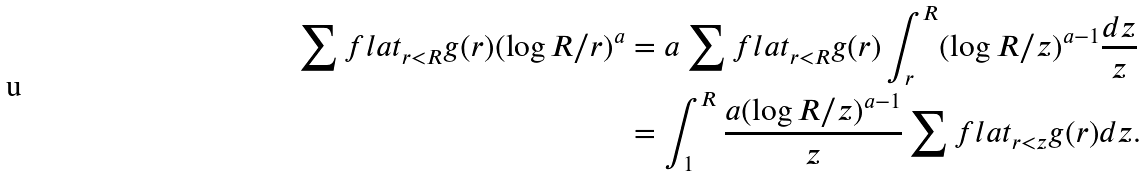Convert formula to latex. <formula><loc_0><loc_0><loc_500><loc_500>\sum f l a t _ { r < R } g ( r ) ( \log R / r ) ^ { a } & = a \sum f l a t _ { r < R } g ( r ) \int _ { r } ^ { R } ( \log R / z ) ^ { a - 1 } \frac { d z } { z } \\ & = \int _ { 1 } ^ { R } \frac { a ( \log R / z ) ^ { a - 1 } } { z } \sum f l a t _ { r < z } g ( r ) d z .</formula> 